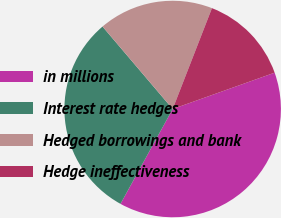Convert chart. <chart><loc_0><loc_0><loc_500><loc_500><pie_chart><fcel>in millions<fcel>Interest rate hedges<fcel>Hedged borrowings and bank<fcel>Hedge ineffectiveness<nl><fcel>38.45%<fcel>30.78%<fcel>17.13%<fcel>13.64%<nl></chart> 